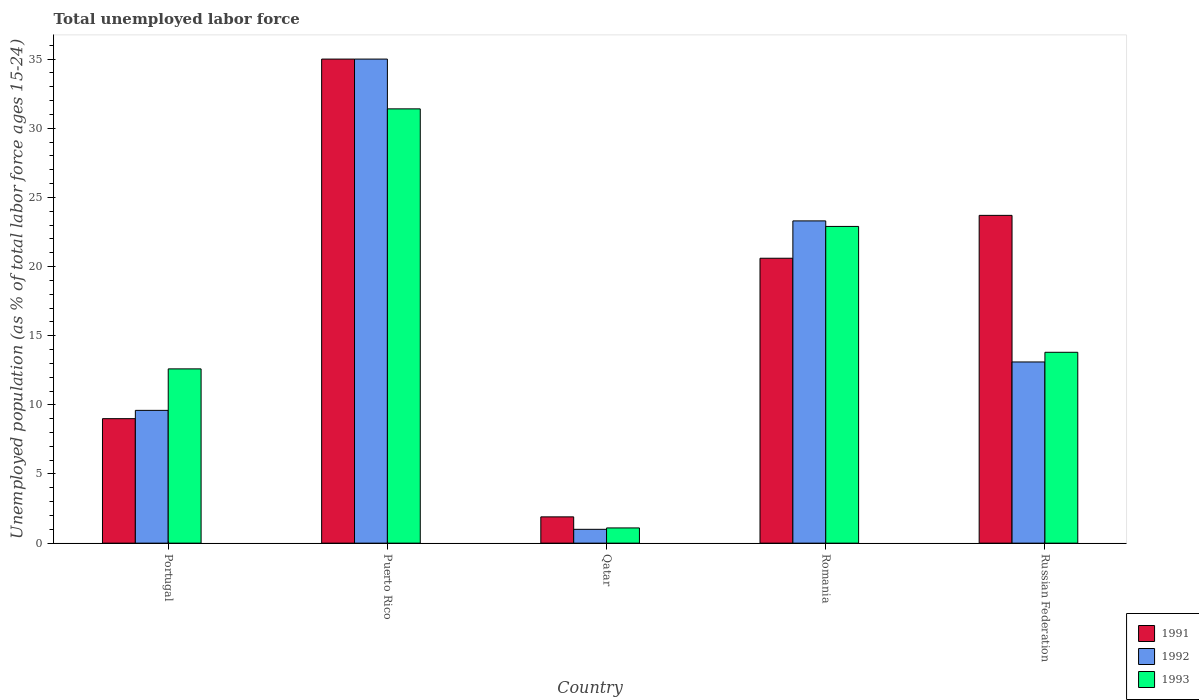How many different coloured bars are there?
Make the answer very short. 3. Are the number of bars per tick equal to the number of legend labels?
Keep it short and to the point. Yes. What is the label of the 4th group of bars from the left?
Give a very brief answer. Romania. What is the percentage of unemployed population in in 1993 in Russian Federation?
Provide a short and direct response. 13.8. Across all countries, what is the maximum percentage of unemployed population in in 1993?
Your response must be concise. 31.4. In which country was the percentage of unemployed population in in 1991 maximum?
Ensure brevity in your answer.  Puerto Rico. In which country was the percentage of unemployed population in in 1992 minimum?
Offer a terse response. Qatar. What is the total percentage of unemployed population in in 1991 in the graph?
Provide a succinct answer. 90.2. What is the difference between the percentage of unemployed population in in 1992 in Qatar and that in Russian Federation?
Offer a terse response. -12.1. What is the difference between the percentage of unemployed population in in 1993 in Portugal and the percentage of unemployed population in in 1991 in Puerto Rico?
Offer a very short reply. -22.4. What is the average percentage of unemployed population in in 1993 per country?
Ensure brevity in your answer.  16.36. What is the difference between the percentage of unemployed population in of/in 1992 and percentage of unemployed population in of/in 1991 in Qatar?
Ensure brevity in your answer.  -0.9. In how many countries, is the percentage of unemployed population in in 1991 greater than 2 %?
Make the answer very short. 4. What is the ratio of the percentage of unemployed population in in 1993 in Qatar to that in Romania?
Give a very brief answer. 0.05. What is the difference between the highest and the second highest percentage of unemployed population in in 1991?
Make the answer very short. 14.4. In how many countries, is the percentage of unemployed population in in 1993 greater than the average percentage of unemployed population in in 1993 taken over all countries?
Provide a short and direct response. 2. Is the sum of the percentage of unemployed population in in 1992 in Portugal and Russian Federation greater than the maximum percentage of unemployed population in in 1991 across all countries?
Keep it short and to the point. No. What does the 1st bar from the left in Puerto Rico represents?
Your answer should be compact. 1991. Is it the case that in every country, the sum of the percentage of unemployed population in in 1992 and percentage of unemployed population in in 1993 is greater than the percentage of unemployed population in in 1991?
Make the answer very short. Yes. How many bars are there?
Offer a very short reply. 15. Are all the bars in the graph horizontal?
Provide a short and direct response. No. What is the difference between two consecutive major ticks on the Y-axis?
Your answer should be compact. 5. Does the graph contain grids?
Your response must be concise. No. Where does the legend appear in the graph?
Ensure brevity in your answer.  Bottom right. How many legend labels are there?
Your answer should be very brief. 3. What is the title of the graph?
Give a very brief answer. Total unemployed labor force. What is the label or title of the Y-axis?
Provide a short and direct response. Unemployed population (as % of total labor force ages 15-24). What is the Unemployed population (as % of total labor force ages 15-24) of 1991 in Portugal?
Give a very brief answer. 9. What is the Unemployed population (as % of total labor force ages 15-24) of 1992 in Portugal?
Your answer should be very brief. 9.6. What is the Unemployed population (as % of total labor force ages 15-24) of 1993 in Portugal?
Make the answer very short. 12.6. What is the Unemployed population (as % of total labor force ages 15-24) of 1991 in Puerto Rico?
Make the answer very short. 35. What is the Unemployed population (as % of total labor force ages 15-24) of 1992 in Puerto Rico?
Ensure brevity in your answer.  35. What is the Unemployed population (as % of total labor force ages 15-24) in 1993 in Puerto Rico?
Your answer should be compact. 31.4. What is the Unemployed population (as % of total labor force ages 15-24) in 1991 in Qatar?
Your answer should be compact. 1.9. What is the Unemployed population (as % of total labor force ages 15-24) in 1993 in Qatar?
Make the answer very short. 1.1. What is the Unemployed population (as % of total labor force ages 15-24) in 1991 in Romania?
Your answer should be very brief. 20.6. What is the Unemployed population (as % of total labor force ages 15-24) of 1992 in Romania?
Keep it short and to the point. 23.3. What is the Unemployed population (as % of total labor force ages 15-24) of 1993 in Romania?
Offer a terse response. 22.9. What is the Unemployed population (as % of total labor force ages 15-24) in 1991 in Russian Federation?
Ensure brevity in your answer.  23.7. What is the Unemployed population (as % of total labor force ages 15-24) of 1992 in Russian Federation?
Provide a short and direct response. 13.1. What is the Unemployed population (as % of total labor force ages 15-24) of 1993 in Russian Federation?
Your answer should be compact. 13.8. Across all countries, what is the maximum Unemployed population (as % of total labor force ages 15-24) of 1992?
Your answer should be compact. 35. Across all countries, what is the maximum Unemployed population (as % of total labor force ages 15-24) in 1993?
Make the answer very short. 31.4. Across all countries, what is the minimum Unemployed population (as % of total labor force ages 15-24) in 1991?
Offer a very short reply. 1.9. Across all countries, what is the minimum Unemployed population (as % of total labor force ages 15-24) of 1993?
Ensure brevity in your answer.  1.1. What is the total Unemployed population (as % of total labor force ages 15-24) in 1991 in the graph?
Give a very brief answer. 90.2. What is the total Unemployed population (as % of total labor force ages 15-24) in 1992 in the graph?
Your answer should be compact. 82. What is the total Unemployed population (as % of total labor force ages 15-24) in 1993 in the graph?
Ensure brevity in your answer.  81.8. What is the difference between the Unemployed population (as % of total labor force ages 15-24) of 1991 in Portugal and that in Puerto Rico?
Your response must be concise. -26. What is the difference between the Unemployed population (as % of total labor force ages 15-24) in 1992 in Portugal and that in Puerto Rico?
Offer a terse response. -25.4. What is the difference between the Unemployed population (as % of total labor force ages 15-24) in 1993 in Portugal and that in Puerto Rico?
Offer a very short reply. -18.8. What is the difference between the Unemployed population (as % of total labor force ages 15-24) in 1991 in Portugal and that in Qatar?
Your answer should be very brief. 7.1. What is the difference between the Unemployed population (as % of total labor force ages 15-24) in 1992 in Portugal and that in Qatar?
Provide a succinct answer. 8.6. What is the difference between the Unemployed population (as % of total labor force ages 15-24) in 1992 in Portugal and that in Romania?
Your response must be concise. -13.7. What is the difference between the Unemployed population (as % of total labor force ages 15-24) in 1991 in Portugal and that in Russian Federation?
Your answer should be very brief. -14.7. What is the difference between the Unemployed population (as % of total labor force ages 15-24) of 1992 in Portugal and that in Russian Federation?
Your answer should be very brief. -3.5. What is the difference between the Unemployed population (as % of total labor force ages 15-24) of 1991 in Puerto Rico and that in Qatar?
Your response must be concise. 33.1. What is the difference between the Unemployed population (as % of total labor force ages 15-24) of 1992 in Puerto Rico and that in Qatar?
Make the answer very short. 34. What is the difference between the Unemployed population (as % of total labor force ages 15-24) in 1993 in Puerto Rico and that in Qatar?
Provide a succinct answer. 30.3. What is the difference between the Unemployed population (as % of total labor force ages 15-24) of 1991 in Puerto Rico and that in Romania?
Offer a terse response. 14.4. What is the difference between the Unemployed population (as % of total labor force ages 15-24) of 1992 in Puerto Rico and that in Romania?
Make the answer very short. 11.7. What is the difference between the Unemployed population (as % of total labor force ages 15-24) of 1993 in Puerto Rico and that in Romania?
Provide a short and direct response. 8.5. What is the difference between the Unemployed population (as % of total labor force ages 15-24) of 1992 in Puerto Rico and that in Russian Federation?
Ensure brevity in your answer.  21.9. What is the difference between the Unemployed population (as % of total labor force ages 15-24) in 1993 in Puerto Rico and that in Russian Federation?
Keep it short and to the point. 17.6. What is the difference between the Unemployed population (as % of total labor force ages 15-24) of 1991 in Qatar and that in Romania?
Offer a terse response. -18.7. What is the difference between the Unemployed population (as % of total labor force ages 15-24) in 1992 in Qatar and that in Romania?
Ensure brevity in your answer.  -22.3. What is the difference between the Unemployed population (as % of total labor force ages 15-24) of 1993 in Qatar and that in Romania?
Make the answer very short. -21.8. What is the difference between the Unemployed population (as % of total labor force ages 15-24) of 1991 in Qatar and that in Russian Federation?
Ensure brevity in your answer.  -21.8. What is the difference between the Unemployed population (as % of total labor force ages 15-24) of 1992 in Qatar and that in Russian Federation?
Make the answer very short. -12.1. What is the difference between the Unemployed population (as % of total labor force ages 15-24) in 1993 in Qatar and that in Russian Federation?
Your answer should be compact. -12.7. What is the difference between the Unemployed population (as % of total labor force ages 15-24) in 1991 in Romania and that in Russian Federation?
Make the answer very short. -3.1. What is the difference between the Unemployed population (as % of total labor force ages 15-24) of 1993 in Romania and that in Russian Federation?
Your response must be concise. 9.1. What is the difference between the Unemployed population (as % of total labor force ages 15-24) of 1991 in Portugal and the Unemployed population (as % of total labor force ages 15-24) of 1993 in Puerto Rico?
Your answer should be compact. -22.4. What is the difference between the Unemployed population (as % of total labor force ages 15-24) in 1992 in Portugal and the Unemployed population (as % of total labor force ages 15-24) in 1993 in Puerto Rico?
Your answer should be very brief. -21.8. What is the difference between the Unemployed population (as % of total labor force ages 15-24) in 1991 in Portugal and the Unemployed population (as % of total labor force ages 15-24) in 1992 in Romania?
Your answer should be compact. -14.3. What is the difference between the Unemployed population (as % of total labor force ages 15-24) of 1992 in Portugal and the Unemployed population (as % of total labor force ages 15-24) of 1993 in Romania?
Your response must be concise. -13.3. What is the difference between the Unemployed population (as % of total labor force ages 15-24) of 1991 in Portugal and the Unemployed population (as % of total labor force ages 15-24) of 1992 in Russian Federation?
Keep it short and to the point. -4.1. What is the difference between the Unemployed population (as % of total labor force ages 15-24) of 1991 in Portugal and the Unemployed population (as % of total labor force ages 15-24) of 1993 in Russian Federation?
Your response must be concise. -4.8. What is the difference between the Unemployed population (as % of total labor force ages 15-24) of 1991 in Puerto Rico and the Unemployed population (as % of total labor force ages 15-24) of 1992 in Qatar?
Your answer should be compact. 34. What is the difference between the Unemployed population (as % of total labor force ages 15-24) in 1991 in Puerto Rico and the Unemployed population (as % of total labor force ages 15-24) in 1993 in Qatar?
Ensure brevity in your answer.  33.9. What is the difference between the Unemployed population (as % of total labor force ages 15-24) in 1992 in Puerto Rico and the Unemployed population (as % of total labor force ages 15-24) in 1993 in Qatar?
Provide a short and direct response. 33.9. What is the difference between the Unemployed population (as % of total labor force ages 15-24) in 1991 in Puerto Rico and the Unemployed population (as % of total labor force ages 15-24) in 1992 in Romania?
Your answer should be compact. 11.7. What is the difference between the Unemployed population (as % of total labor force ages 15-24) of 1991 in Puerto Rico and the Unemployed population (as % of total labor force ages 15-24) of 1993 in Romania?
Your answer should be compact. 12.1. What is the difference between the Unemployed population (as % of total labor force ages 15-24) of 1991 in Puerto Rico and the Unemployed population (as % of total labor force ages 15-24) of 1992 in Russian Federation?
Your answer should be compact. 21.9. What is the difference between the Unemployed population (as % of total labor force ages 15-24) in 1991 in Puerto Rico and the Unemployed population (as % of total labor force ages 15-24) in 1993 in Russian Federation?
Provide a short and direct response. 21.2. What is the difference between the Unemployed population (as % of total labor force ages 15-24) in 1992 in Puerto Rico and the Unemployed population (as % of total labor force ages 15-24) in 1993 in Russian Federation?
Your answer should be very brief. 21.2. What is the difference between the Unemployed population (as % of total labor force ages 15-24) of 1991 in Qatar and the Unemployed population (as % of total labor force ages 15-24) of 1992 in Romania?
Make the answer very short. -21.4. What is the difference between the Unemployed population (as % of total labor force ages 15-24) of 1991 in Qatar and the Unemployed population (as % of total labor force ages 15-24) of 1993 in Romania?
Offer a very short reply. -21. What is the difference between the Unemployed population (as % of total labor force ages 15-24) in 1992 in Qatar and the Unemployed population (as % of total labor force ages 15-24) in 1993 in Romania?
Offer a terse response. -21.9. What is the difference between the Unemployed population (as % of total labor force ages 15-24) of 1991 in Romania and the Unemployed population (as % of total labor force ages 15-24) of 1992 in Russian Federation?
Provide a succinct answer. 7.5. What is the difference between the Unemployed population (as % of total labor force ages 15-24) in 1991 in Romania and the Unemployed population (as % of total labor force ages 15-24) in 1993 in Russian Federation?
Provide a short and direct response. 6.8. What is the difference between the Unemployed population (as % of total labor force ages 15-24) in 1992 in Romania and the Unemployed population (as % of total labor force ages 15-24) in 1993 in Russian Federation?
Provide a succinct answer. 9.5. What is the average Unemployed population (as % of total labor force ages 15-24) in 1991 per country?
Your answer should be compact. 18.04. What is the average Unemployed population (as % of total labor force ages 15-24) of 1993 per country?
Offer a terse response. 16.36. What is the difference between the Unemployed population (as % of total labor force ages 15-24) of 1991 and Unemployed population (as % of total labor force ages 15-24) of 1992 in Portugal?
Your response must be concise. -0.6. What is the difference between the Unemployed population (as % of total labor force ages 15-24) of 1991 and Unemployed population (as % of total labor force ages 15-24) of 1993 in Portugal?
Give a very brief answer. -3.6. What is the difference between the Unemployed population (as % of total labor force ages 15-24) of 1992 and Unemployed population (as % of total labor force ages 15-24) of 1993 in Portugal?
Offer a terse response. -3. What is the difference between the Unemployed population (as % of total labor force ages 15-24) in 1991 and Unemployed population (as % of total labor force ages 15-24) in 1993 in Puerto Rico?
Make the answer very short. 3.6. What is the difference between the Unemployed population (as % of total labor force ages 15-24) in 1992 and Unemployed population (as % of total labor force ages 15-24) in 1993 in Qatar?
Give a very brief answer. -0.1. What is the difference between the Unemployed population (as % of total labor force ages 15-24) in 1991 and Unemployed population (as % of total labor force ages 15-24) in 1993 in Romania?
Keep it short and to the point. -2.3. What is the difference between the Unemployed population (as % of total labor force ages 15-24) of 1992 and Unemployed population (as % of total labor force ages 15-24) of 1993 in Romania?
Provide a short and direct response. 0.4. What is the difference between the Unemployed population (as % of total labor force ages 15-24) of 1991 and Unemployed population (as % of total labor force ages 15-24) of 1992 in Russian Federation?
Make the answer very short. 10.6. What is the difference between the Unemployed population (as % of total labor force ages 15-24) of 1992 and Unemployed population (as % of total labor force ages 15-24) of 1993 in Russian Federation?
Ensure brevity in your answer.  -0.7. What is the ratio of the Unemployed population (as % of total labor force ages 15-24) in 1991 in Portugal to that in Puerto Rico?
Provide a succinct answer. 0.26. What is the ratio of the Unemployed population (as % of total labor force ages 15-24) in 1992 in Portugal to that in Puerto Rico?
Provide a succinct answer. 0.27. What is the ratio of the Unemployed population (as % of total labor force ages 15-24) of 1993 in Portugal to that in Puerto Rico?
Your answer should be very brief. 0.4. What is the ratio of the Unemployed population (as % of total labor force ages 15-24) in 1991 in Portugal to that in Qatar?
Your answer should be very brief. 4.74. What is the ratio of the Unemployed population (as % of total labor force ages 15-24) in 1992 in Portugal to that in Qatar?
Ensure brevity in your answer.  9.6. What is the ratio of the Unemployed population (as % of total labor force ages 15-24) of 1993 in Portugal to that in Qatar?
Keep it short and to the point. 11.45. What is the ratio of the Unemployed population (as % of total labor force ages 15-24) of 1991 in Portugal to that in Romania?
Your answer should be compact. 0.44. What is the ratio of the Unemployed population (as % of total labor force ages 15-24) in 1992 in Portugal to that in Romania?
Provide a short and direct response. 0.41. What is the ratio of the Unemployed population (as % of total labor force ages 15-24) in 1993 in Portugal to that in Romania?
Your response must be concise. 0.55. What is the ratio of the Unemployed population (as % of total labor force ages 15-24) of 1991 in Portugal to that in Russian Federation?
Offer a very short reply. 0.38. What is the ratio of the Unemployed population (as % of total labor force ages 15-24) of 1992 in Portugal to that in Russian Federation?
Provide a succinct answer. 0.73. What is the ratio of the Unemployed population (as % of total labor force ages 15-24) of 1993 in Portugal to that in Russian Federation?
Offer a very short reply. 0.91. What is the ratio of the Unemployed population (as % of total labor force ages 15-24) of 1991 in Puerto Rico to that in Qatar?
Your response must be concise. 18.42. What is the ratio of the Unemployed population (as % of total labor force ages 15-24) in 1993 in Puerto Rico to that in Qatar?
Offer a very short reply. 28.55. What is the ratio of the Unemployed population (as % of total labor force ages 15-24) of 1991 in Puerto Rico to that in Romania?
Keep it short and to the point. 1.7. What is the ratio of the Unemployed population (as % of total labor force ages 15-24) in 1992 in Puerto Rico to that in Romania?
Make the answer very short. 1.5. What is the ratio of the Unemployed population (as % of total labor force ages 15-24) in 1993 in Puerto Rico to that in Romania?
Your answer should be very brief. 1.37. What is the ratio of the Unemployed population (as % of total labor force ages 15-24) in 1991 in Puerto Rico to that in Russian Federation?
Keep it short and to the point. 1.48. What is the ratio of the Unemployed population (as % of total labor force ages 15-24) in 1992 in Puerto Rico to that in Russian Federation?
Keep it short and to the point. 2.67. What is the ratio of the Unemployed population (as % of total labor force ages 15-24) in 1993 in Puerto Rico to that in Russian Federation?
Your answer should be very brief. 2.28. What is the ratio of the Unemployed population (as % of total labor force ages 15-24) of 1991 in Qatar to that in Romania?
Offer a very short reply. 0.09. What is the ratio of the Unemployed population (as % of total labor force ages 15-24) in 1992 in Qatar to that in Romania?
Make the answer very short. 0.04. What is the ratio of the Unemployed population (as % of total labor force ages 15-24) in 1993 in Qatar to that in Romania?
Ensure brevity in your answer.  0.05. What is the ratio of the Unemployed population (as % of total labor force ages 15-24) in 1991 in Qatar to that in Russian Federation?
Offer a very short reply. 0.08. What is the ratio of the Unemployed population (as % of total labor force ages 15-24) of 1992 in Qatar to that in Russian Federation?
Provide a succinct answer. 0.08. What is the ratio of the Unemployed population (as % of total labor force ages 15-24) in 1993 in Qatar to that in Russian Federation?
Keep it short and to the point. 0.08. What is the ratio of the Unemployed population (as % of total labor force ages 15-24) of 1991 in Romania to that in Russian Federation?
Keep it short and to the point. 0.87. What is the ratio of the Unemployed population (as % of total labor force ages 15-24) in 1992 in Romania to that in Russian Federation?
Offer a terse response. 1.78. What is the ratio of the Unemployed population (as % of total labor force ages 15-24) in 1993 in Romania to that in Russian Federation?
Provide a short and direct response. 1.66. What is the difference between the highest and the second highest Unemployed population (as % of total labor force ages 15-24) of 1991?
Keep it short and to the point. 11.3. What is the difference between the highest and the second highest Unemployed population (as % of total labor force ages 15-24) in 1992?
Offer a terse response. 11.7. What is the difference between the highest and the second highest Unemployed population (as % of total labor force ages 15-24) of 1993?
Offer a terse response. 8.5. What is the difference between the highest and the lowest Unemployed population (as % of total labor force ages 15-24) in 1991?
Ensure brevity in your answer.  33.1. What is the difference between the highest and the lowest Unemployed population (as % of total labor force ages 15-24) in 1993?
Make the answer very short. 30.3. 